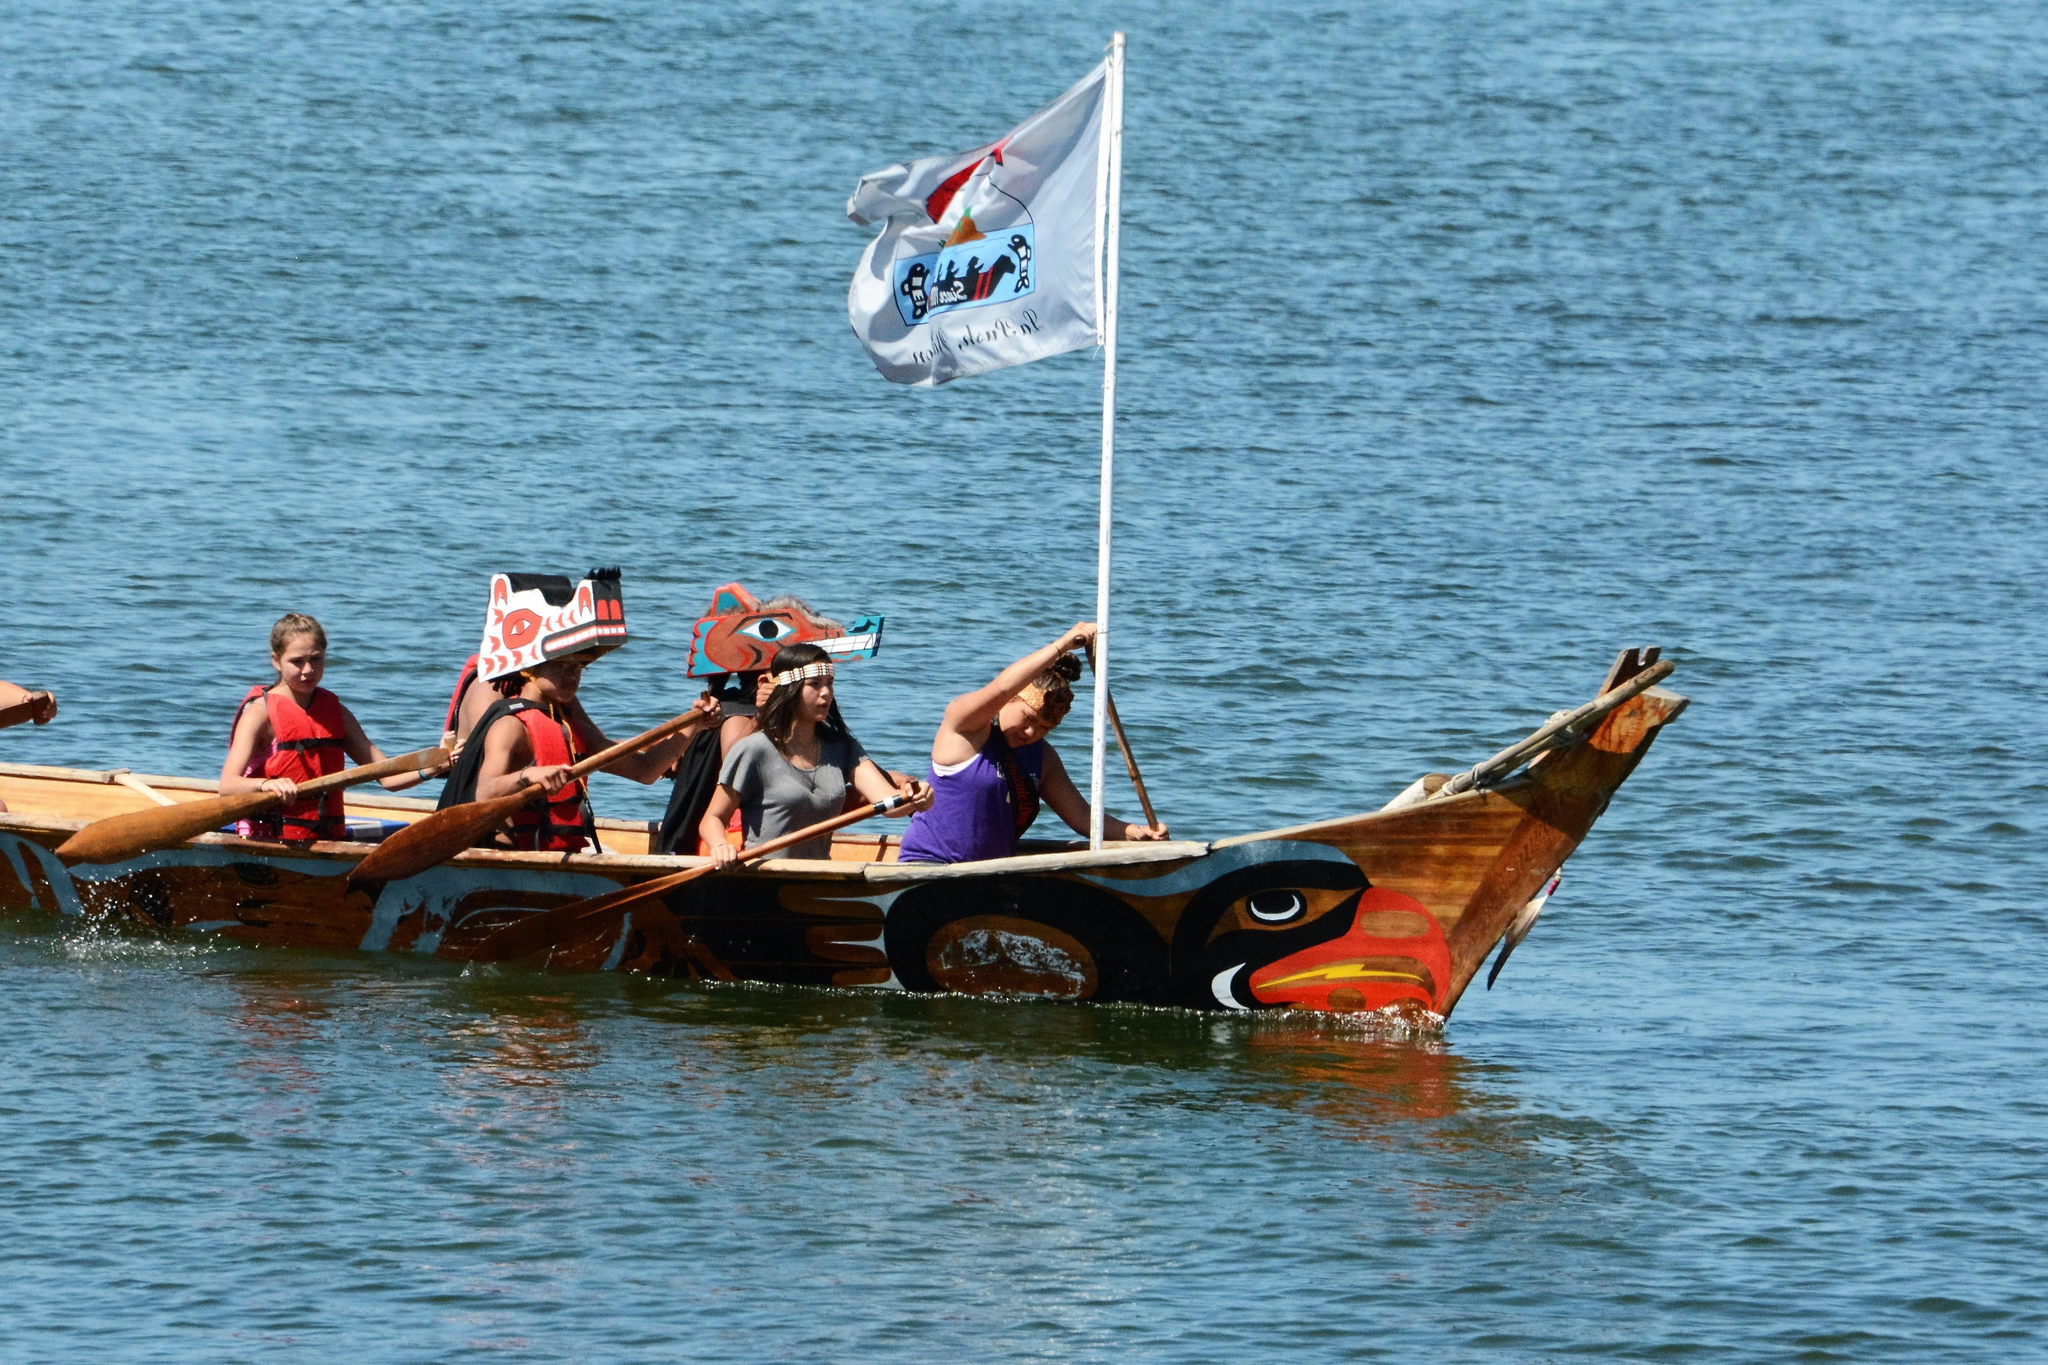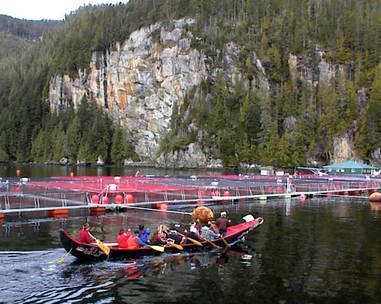The first image is the image on the left, the second image is the image on the right. Examine the images to the left and right. Is the description "Each image shows just one boat in the foreground." accurate? Answer yes or no. Yes. 